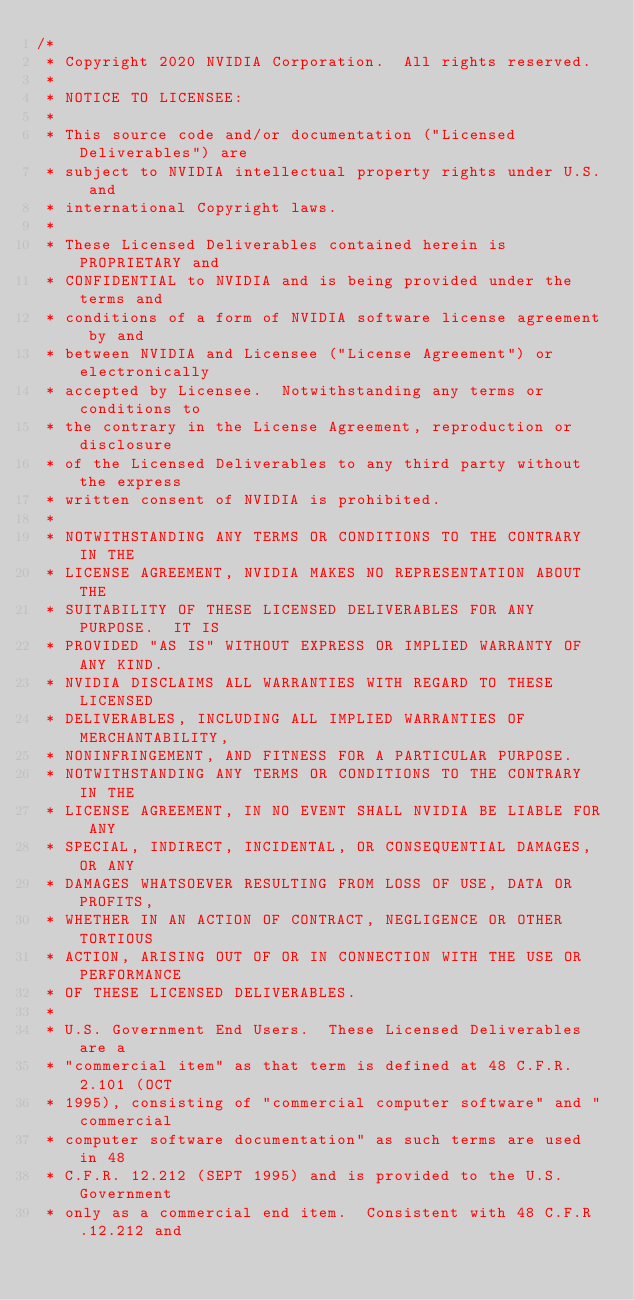Convert code to text. <code><loc_0><loc_0><loc_500><loc_500><_Cuda_>/*
 * Copyright 2020 NVIDIA Corporation.  All rights reserved.
 *
 * NOTICE TO LICENSEE:
 *
 * This source code and/or documentation ("Licensed Deliverables") are
 * subject to NVIDIA intellectual property rights under U.S. and
 * international Copyright laws.
 *
 * These Licensed Deliverables contained herein is PROPRIETARY and
 * CONFIDENTIAL to NVIDIA and is being provided under the terms and
 * conditions of a form of NVIDIA software license agreement by and
 * between NVIDIA and Licensee ("License Agreement") or electronically
 * accepted by Licensee.  Notwithstanding any terms or conditions to
 * the contrary in the License Agreement, reproduction or disclosure
 * of the Licensed Deliverables to any third party without the express
 * written consent of NVIDIA is prohibited.
 *
 * NOTWITHSTANDING ANY TERMS OR CONDITIONS TO THE CONTRARY IN THE
 * LICENSE AGREEMENT, NVIDIA MAKES NO REPRESENTATION ABOUT THE
 * SUITABILITY OF THESE LICENSED DELIVERABLES FOR ANY PURPOSE.  IT IS
 * PROVIDED "AS IS" WITHOUT EXPRESS OR IMPLIED WARRANTY OF ANY KIND.
 * NVIDIA DISCLAIMS ALL WARRANTIES WITH REGARD TO THESE LICENSED
 * DELIVERABLES, INCLUDING ALL IMPLIED WARRANTIES OF MERCHANTABILITY,
 * NONINFRINGEMENT, AND FITNESS FOR A PARTICULAR PURPOSE.
 * NOTWITHSTANDING ANY TERMS OR CONDITIONS TO THE CONTRARY IN THE
 * LICENSE AGREEMENT, IN NO EVENT SHALL NVIDIA BE LIABLE FOR ANY
 * SPECIAL, INDIRECT, INCIDENTAL, OR CONSEQUENTIAL DAMAGES, OR ANY
 * DAMAGES WHATSOEVER RESULTING FROM LOSS OF USE, DATA OR PROFITS,
 * WHETHER IN AN ACTION OF CONTRACT, NEGLIGENCE OR OTHER TORTIOUS
 * ACTION, ARISING OUT OF OR IN CONNECTION WITH THE USE OR PERFORMANCE
 * OF THESE LICENSED DELIVERABLES.
 *
 * U.S. Government End Users.  These Licensed Deliverables are a
 * "commercial item" as that term is defined at 48 C.F.R. 2.101 (OCT
 * 1995), consisting of "commercial computer software" and "commercial
 * computer software documentation" as such terms are used in 48
 * C.F.R. 12.212 (SEPT 1995) and is provided to the U.S. Government
 * only as a commercial end item.  Consistent with 48 C.F.R.12.212 and</code> 